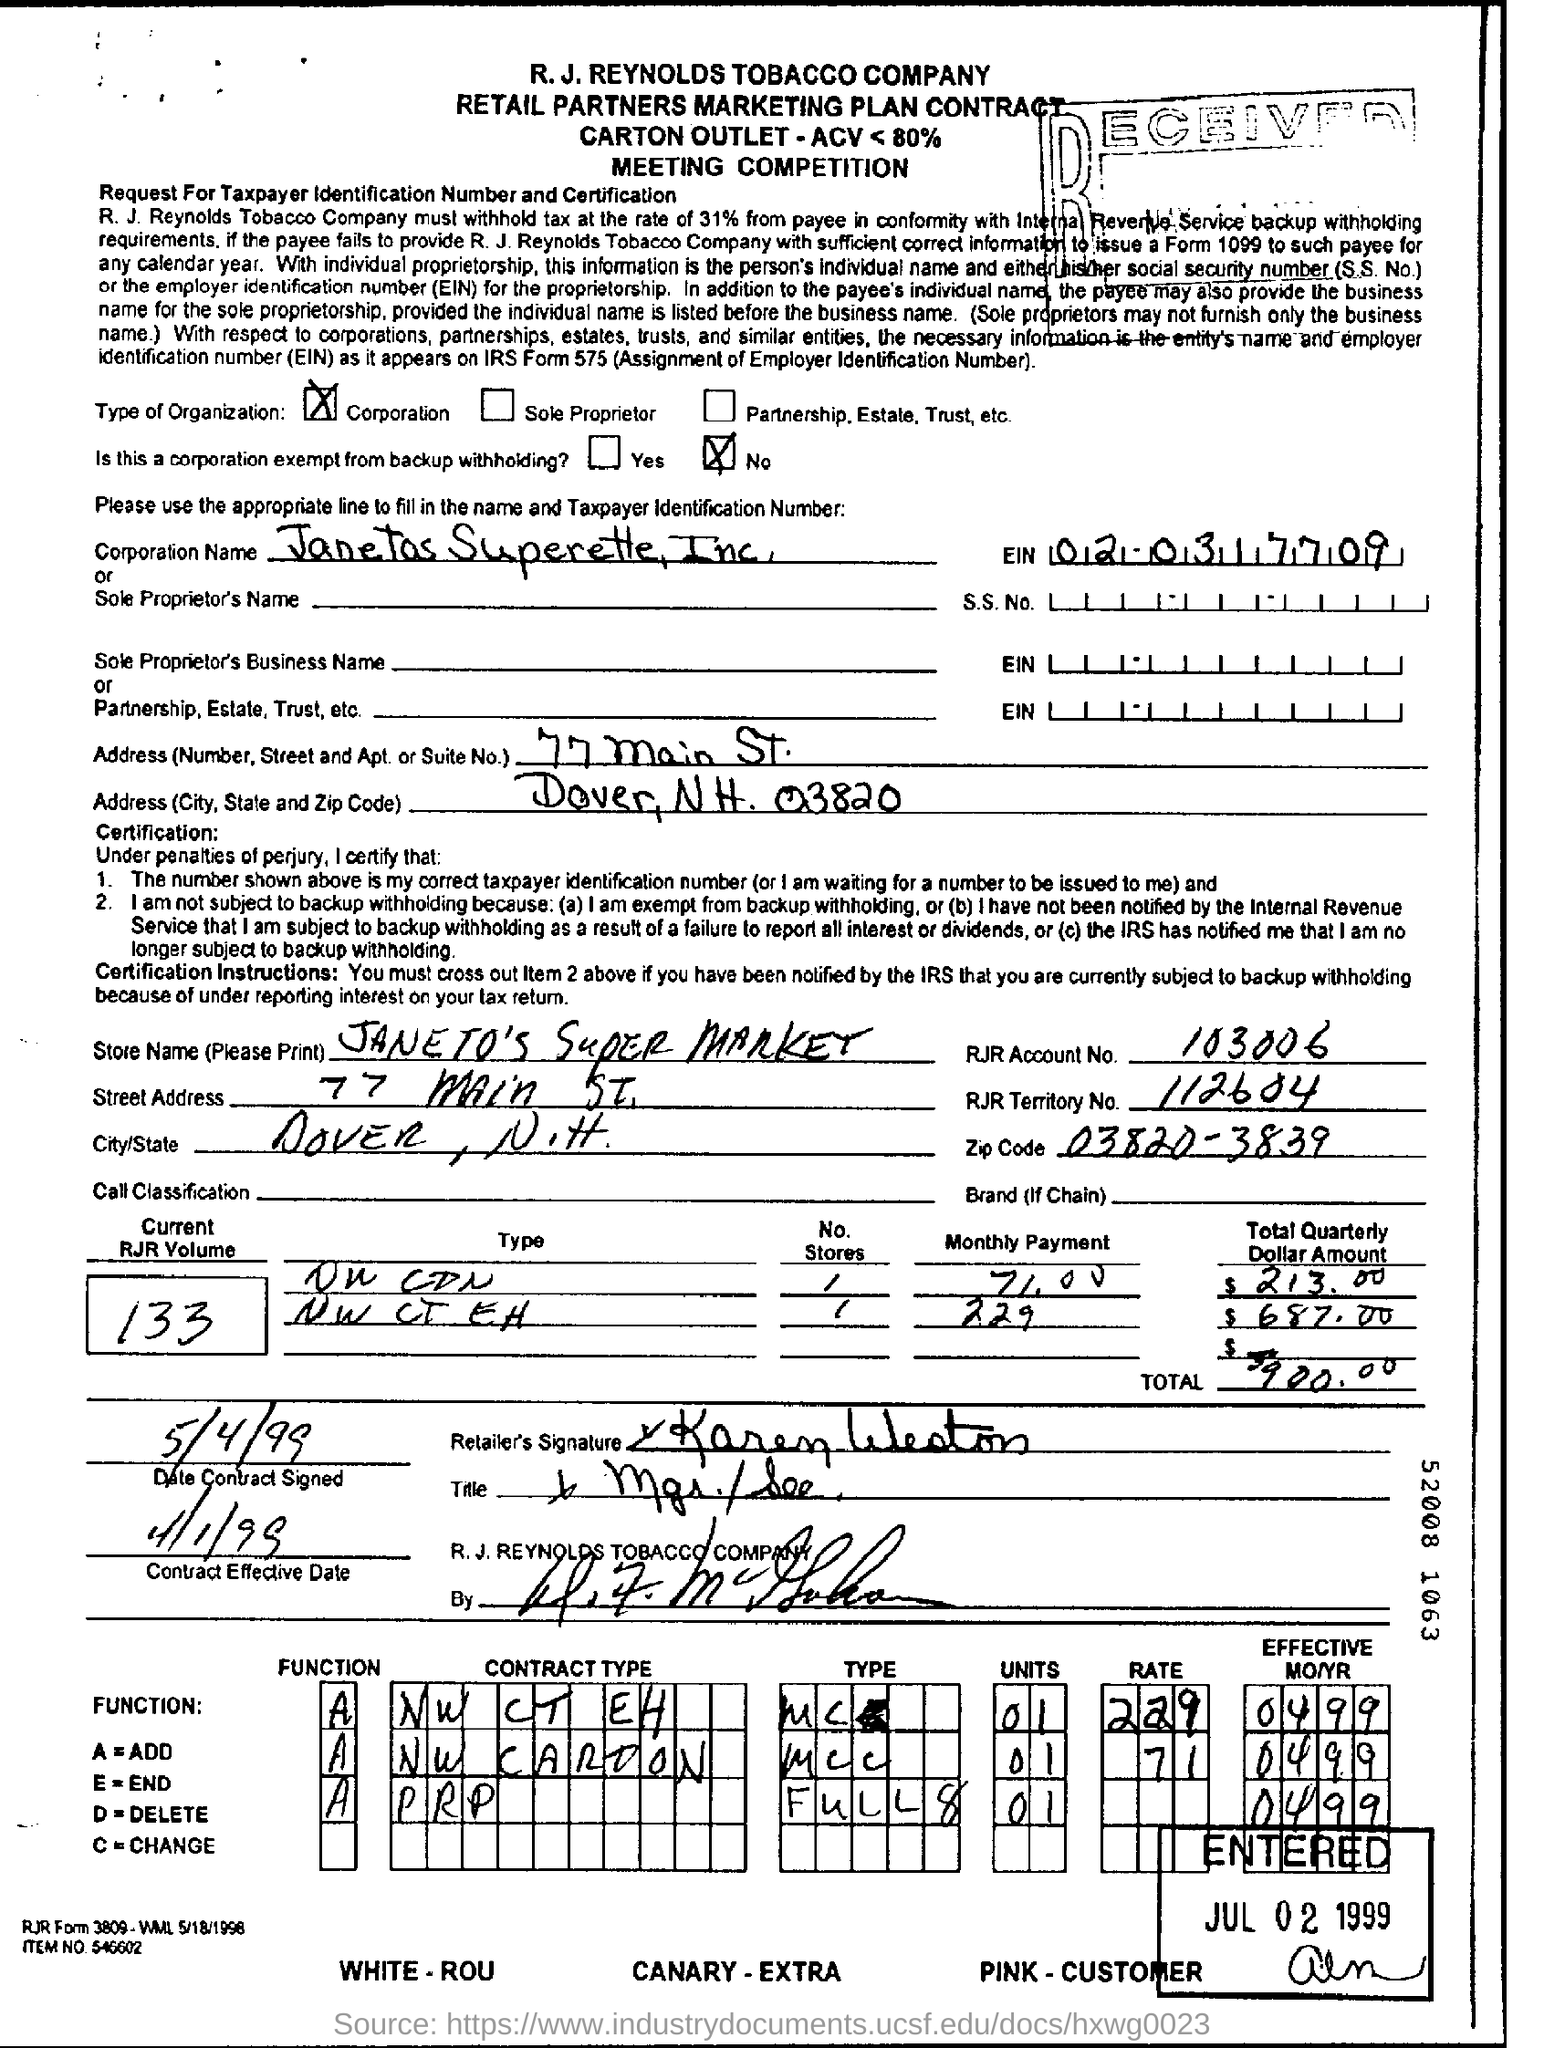What is the Store Name given in the document?
Your answer should be compact. JANETO'S SUPER MARKET. What is the current RJR Volume mentioned in the document?
Provide a succinct answer. 133. What is the RJR Account No?
Your answer should be compact. 103006. What is RJR Territory No given in the document?
Provide a short and direct response. 112604. What is the Date of contract Signed?
Offer a very short reply. 5/4/99. What is the zipcode mentioned in this document?
Your answer should be compact. 03820-3839. Is this a corporation exempt from backup withholding?
Your response must be concise. No. 